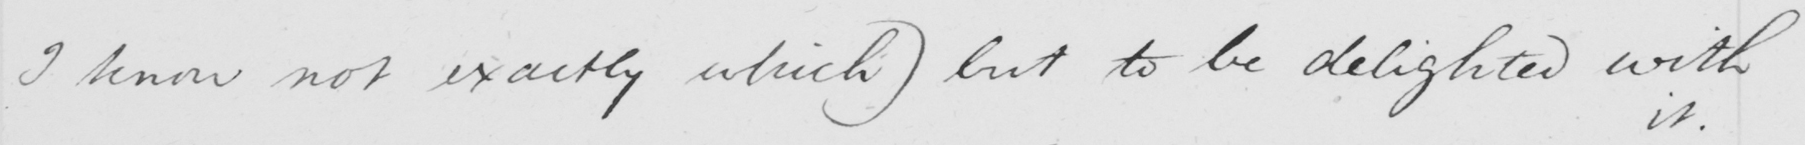Transcribe the text shown in this historical manuscript line. I know not exactly which )  but to be delighted with 